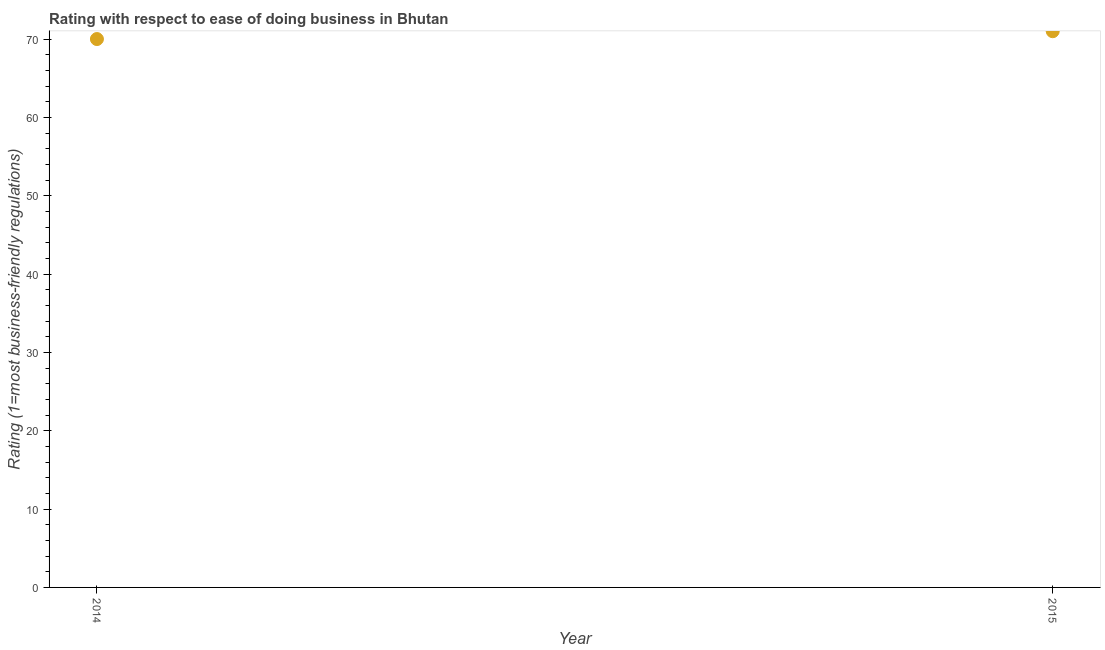What is the ease of doing business index in 2014?
Keep it short and to the point. 70. Across all years, what is the maximum ease of doing business index?
Give a very brief answer. 71. Across all years, what is the minimum ease of doing business index?
Offer a very short reply. 70. In which year was the ease of doing business index maximum?
Keep it short and to the point. 2015. What is the sum of the ease of doing business index?
Provide a short and direct response. 141. What is the difference between the ease of doing business index in 2014 and 2015?
Offer a terse response. -1. What is the average ease of doing business index per year?
Your response must be concise. 70.5. What is the median ease of doing business index?
Offer a very short reply. 70.5. Do a majority of the years between 2015 and 2014 (inclusive) have ease of doing business index greater than 60 ?
Ensure brevity in your answer.  No. What is the ratio of the ease of doing business index in 2014 to that in 2015?
Provide a short and direct response. 0.99. Is the ease of doing business index in 2014 less than that in 2015?
Your answer should be compact. Yes. In how many years, is the ease of doing business index greater than the average ease of doing business index taken over all years?
Offer a very short reply. 1. Does the ease of doing business index monotonically increase over the years?
Provide a succinct answer. Yes. How many dotlines are there?
Offer a very short reply. 1. How many years are there in the graph?
Offer a very short reply. 2. Does the graph contain any zero values?
Make the answer very short. No. Does the graph contain grids?
Offer a terse response. No. What is the title of the graph?
Keep it short and to the point. Rating with respect to ease of doing business in Bhutan. What is the label or title of the X-axis?
Offer a terse response. Year. What is the label or title of the Y-axis?
Your answer should be compact. Rating (1=most business-friendly regulations). What is the Rating (1=most business-friendly regulations) in 2014?
Offer a very short reply. 70. What is the ratio of the Rating (1=most business-friendly regulations) in 2014 to that in 2015?
Your answer should be compact. 0.99. 